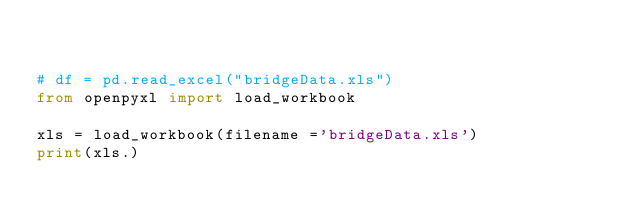Convert code to text. <code><loc_0><loc_0><loc_500><loc_500><_Python_> 

# df = pd.read_excel("bridgeData.xls")
from openpyxl import load_workbook

xls = load_workbook(filename ='bridgeData.xls')
print(xls.)
</code> 